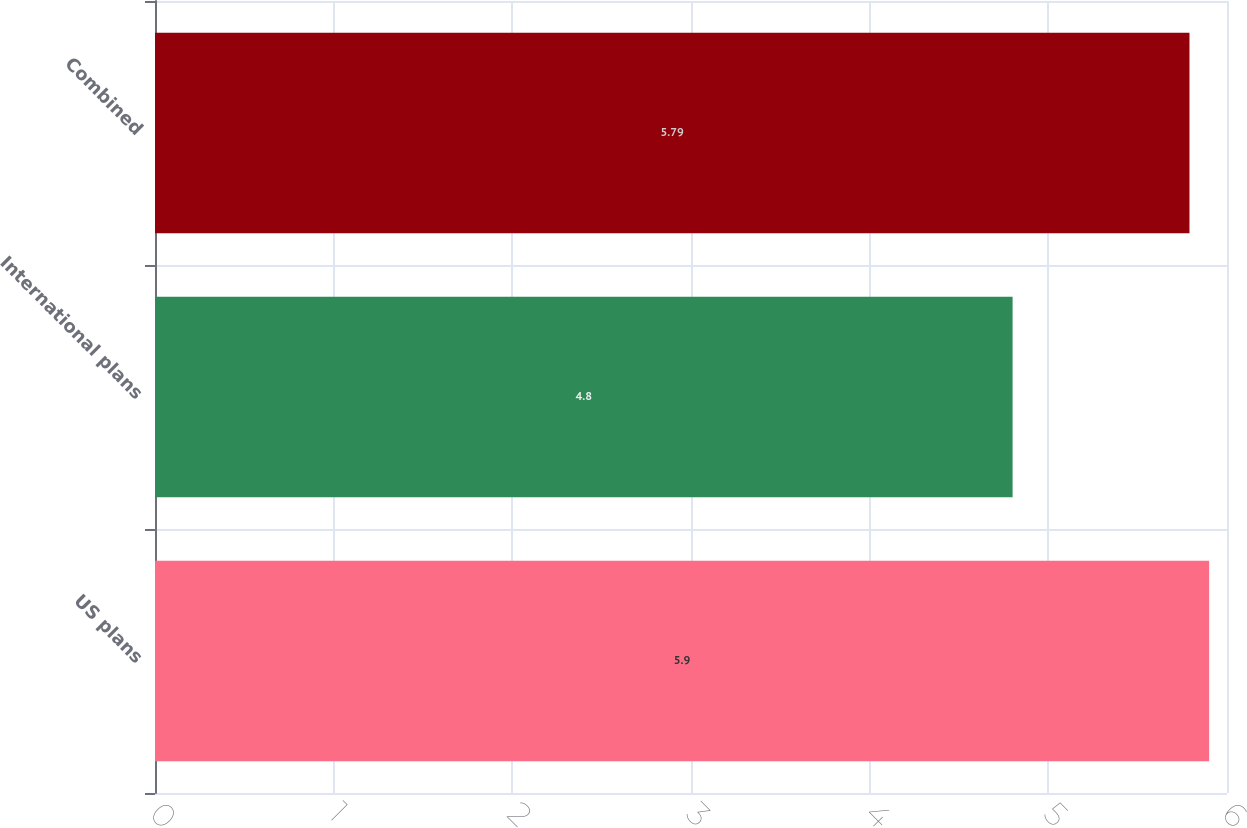Convert chart to OTSL. <chart><loc_0><loc_0><loc_500><loc_500><bar_chart><fcel>US plans<fcel>International plans<fcel>Combined<nl><fcel>5.9<fcel>4.8<fcel>5.79<nl></chart> 